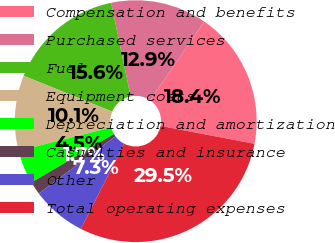<chart> <loc_0><loc_0><loc_500><loc_500><pie_chart><fcel>Compensation and benefits<fcel>Purchased services<fcel>Fuel<fcel>Equipment costs<fcel>Depreciation and amortization<fcel>Casualties and insurance<fcel>Other<fcel>Total operating expenses<nl><fcel>18.4%<fcel>12.85%<fcel>15.62%<fcel>10.07%<fcel>4.52%<fcel>1.74%<fcel>7.29%<fcel>29.5%<nl></chart> 